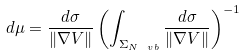Convert formula to latex. <formula><loc_0><loc_0><loc_500><loc_500>d \mu = \frac { d \sigma } { \| \nabla V \| } \left ( \int _ { \Sigma _ { N \ v b } } \frac { d \sigma } { \| \nabla V \| } \right ) ^ { - 1 }</formula> 